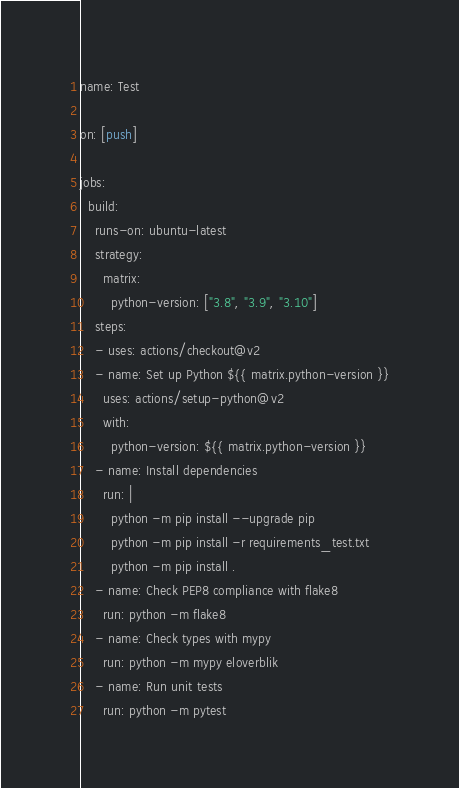<code> <loc_0><loc_0><loc_500><loc_500><_YAML_>name: Test

on: [push]

jobs:
  build:
    runs-on: ubuntu-latest
    strategy:
      matrix:
        python-version: ["3.8", "3.9", "3.10"]
    steps:
    - uses: actions/checkout@v2
    - name: Set up Python ${{ matrix.python-version }}
      uses: actions/setup-python@v2
      with:
        python-version: ${{ matrix.python-version }}
    - name: Install dependencies
      run: |
        python -m pip install --upgrade pip
        python -m pip install -r requirements_test.txt
        python -m pip install .
    - name: Check PEP8 compliance with flake8
      run: python -m flake8
    - name: Check types with mypy
      run: python -m mypy eloverblik
    - name: Run unit tests
      run: python -m pytest
</code> 